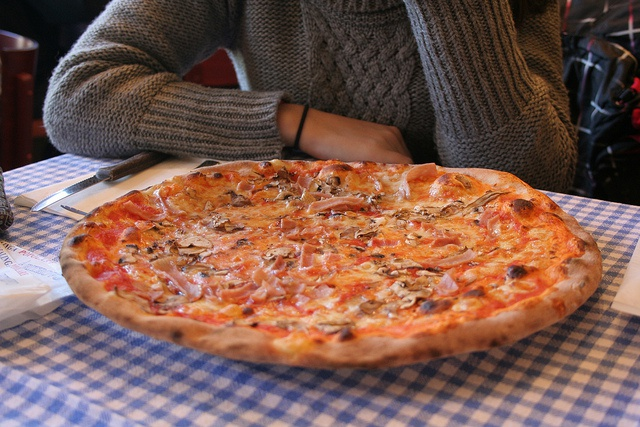Describe the objects in this image and their specific colors. I can see dining table in black, tan, brown, and red tones, pizza in black, brown, tan, red, and salmon tones, people in black, maroon, and gray tones, knife in black, gray, white, and maroon tones, and fork in black, gray, and darkgray tones in this image. 